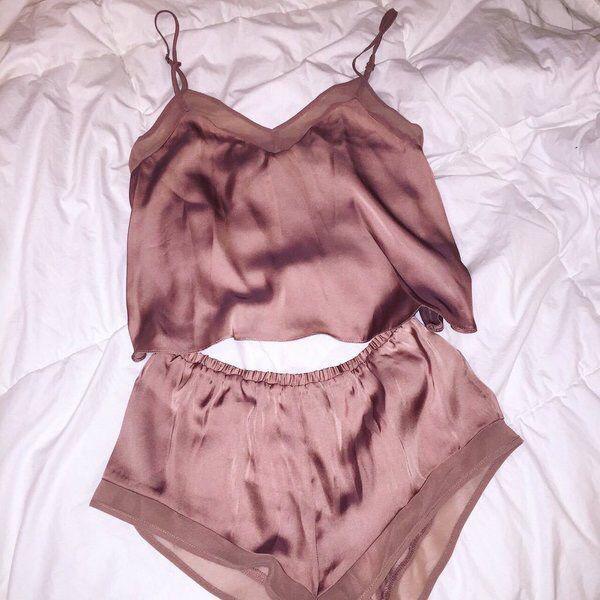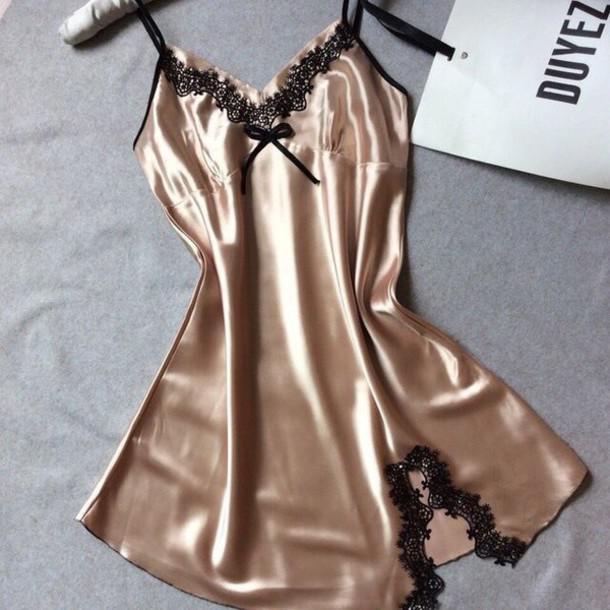The first image is the image on the left, the second image is the image on the right. Considering the images on both sides, is "At least one pajama is one piece and has a card or paper near it was a brand name." valid? Answer yes or no. Yes. The first image is the image on the left, the second image is the image on the right. Considering the images on both sides, is "There is only one single piece outfit and only one two piece outfit." valid? Answer yes or no. Yes. 